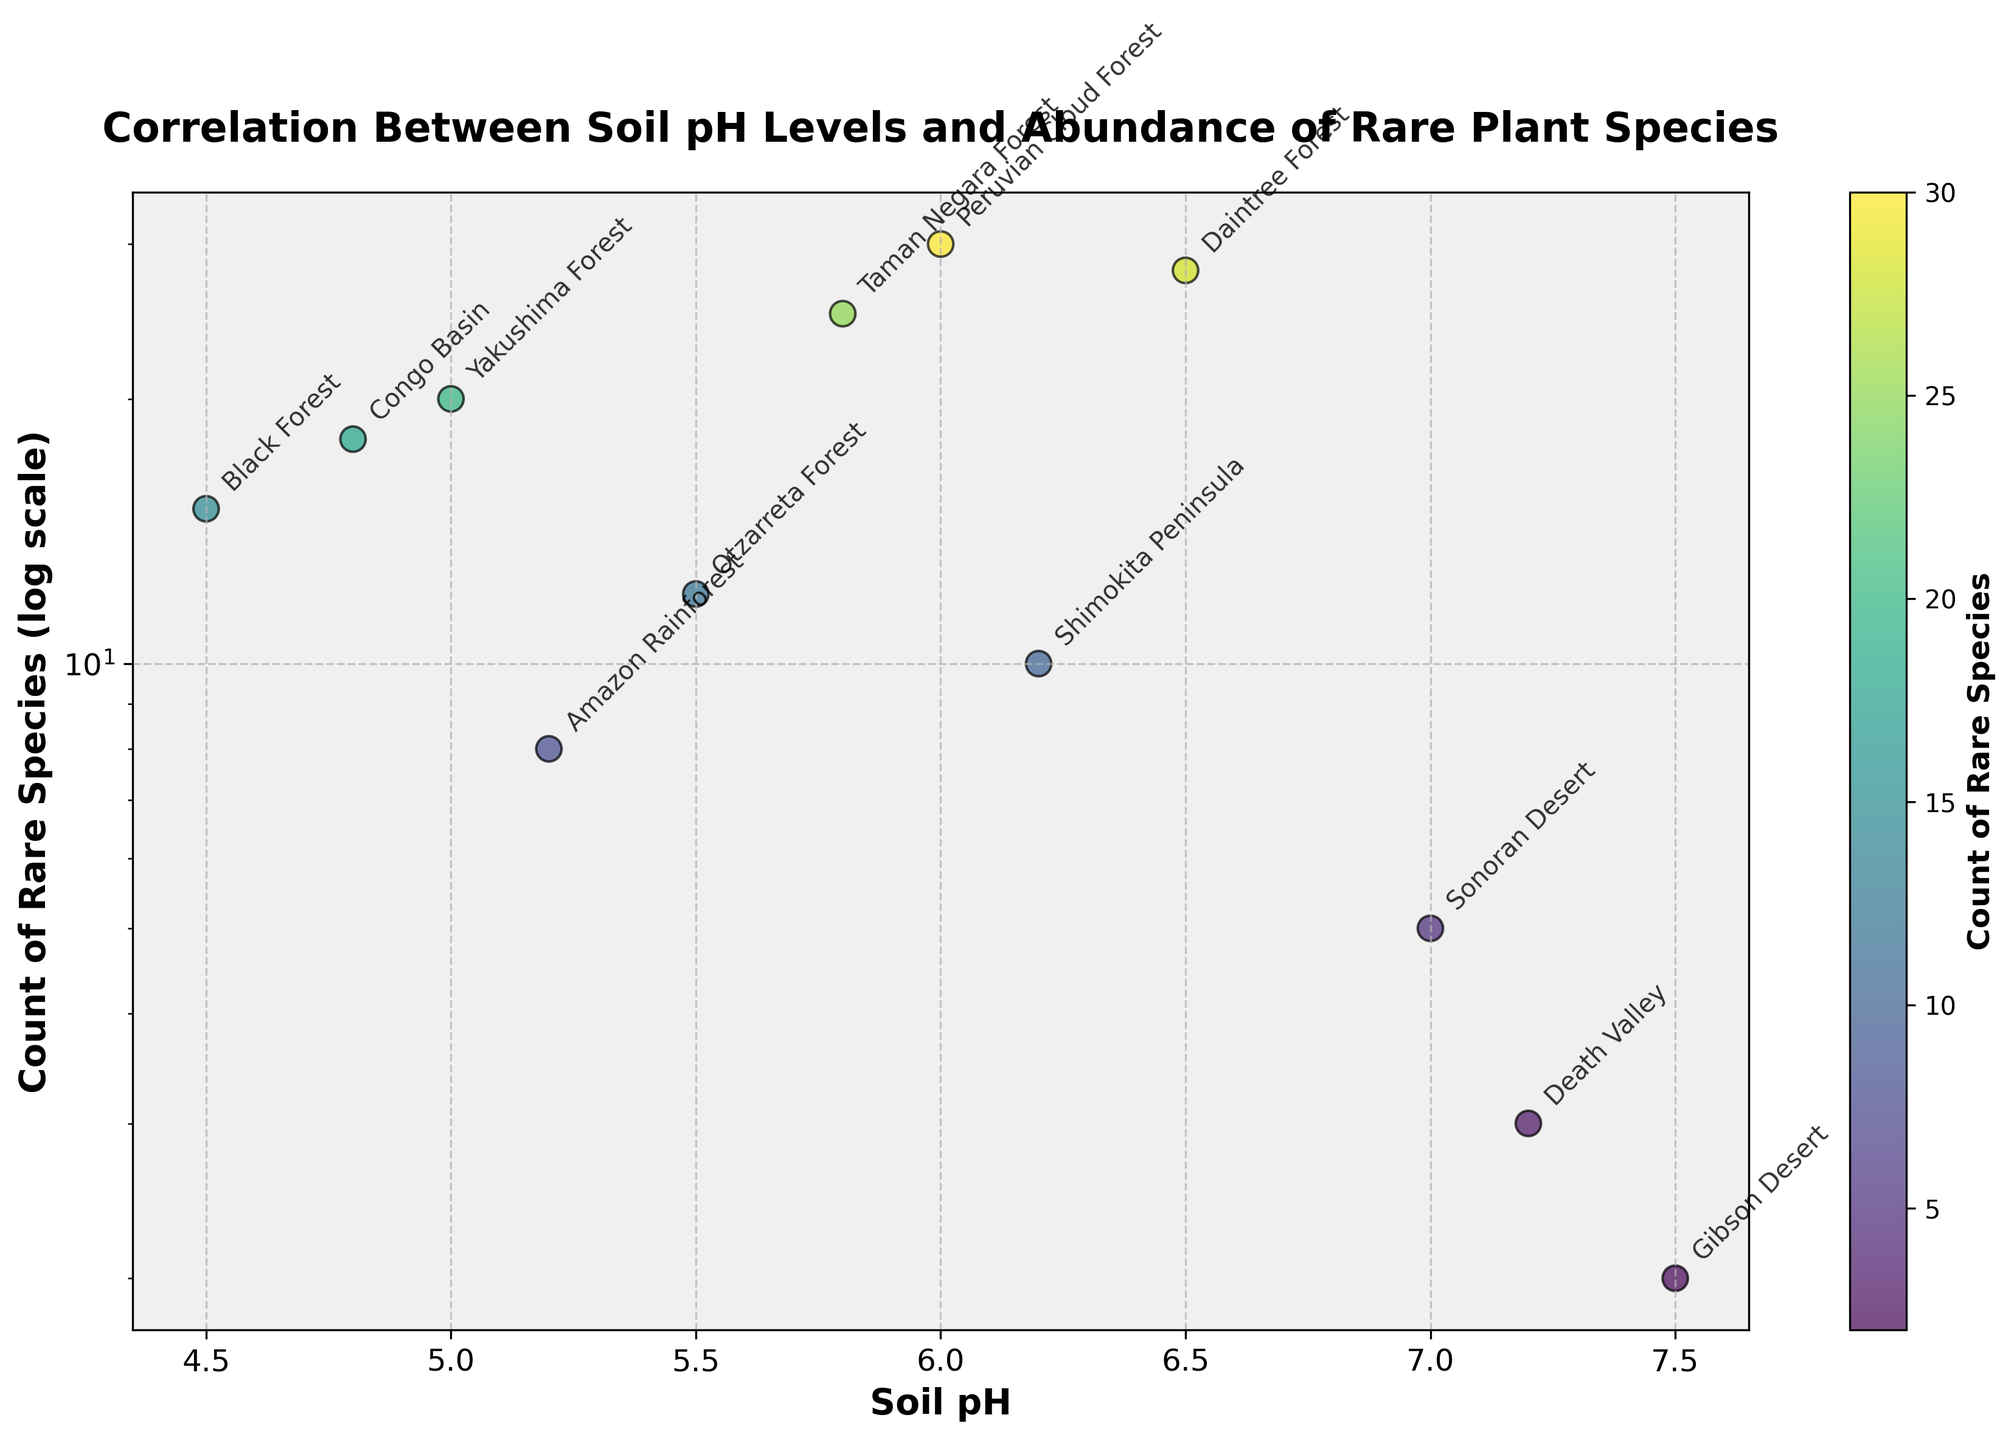What is the title of the plot? The title of the plot is typically found at the top center of the figure. Reading from the provided description, the title is "Correlation Between Soil pH Levels and Abundance of Rare Plant Species".
Answer: Correlation Between Soil pH Levels and Abundance of Rare Plant Species What are the two variables plotted on the axis? The variables are indicated by the axis labels. The x-axis shows "Soil pH" and the y-axis shows "Count of Rare Species (log scale)".
Answer: Soil pH and Count of Rare Species (log scale) How many locations have a Soil pH greater than 6.0? To answer this, look at the x-axis for values greater than 6.0 and count the number of corresponding data points. The locations are Sonoran Desert, Death Valley, and Gibson Desert. There are three points.
Answer: 3 Which location has the highest count of rare species? Look at the y-axis and identify the highest point on the scatter plot. The location with the highest count of rare species is the Peruvian Cloud Forest with a count of 30.
Answer: Peruvian Cloud Forest Which location has the lowest count of rare species? Look for the lowest point on the y-axis in the scatter plot. The location with the lowest count of rare species is the Gibson Desert with a count of 2.
Answer: Gibson Desert What is the soil pH level where the count of rare species is 18? Find the data point where the y-axis shows 18, then check the x-axis for the corresponding Soil pH level. The soil pH level is 4.8, corresponding to the Congo Basin.
Answer: 4.8 Compare the count of rare species between the Black Forest and the Sonoran Desert. Which one has more rare species? Locate the points for Black Forest and Sonoran Desert. Compare their y-axis values. Black Forest has a count of 15, while Sonoran Desert has a count of 5. Therefore, Black Forest has more rare species.
Answer: Black Forest Is there a general trend between Soil pH levels and the abundance of rare plant species? Observing the scatter plot, most points with higher counts of rare species tend to cluster around lower to mid soil pH levels, hinting at a negative correlation. As pH level increases, the count of rare species generally decreases.
Answer: Negative correlation What is the average Soil pH level for locations with more than 10 rare species? First, identify points with y-values greater than 10 (4.5, 5.0, 5.5, 6.0, 5.8, 6.5). Sum their x-values and divide by the number of points: (4.5 + 5.0 + 5.5 + 6.0 + 5.8 + 6.5)/6 = 33.3 / 6 ≈ 5.55.
Answer: 5.55 Which location has a Soil pH of exactly 5.0? Check the scatter plot for the point where the x-axis is at 5.0 and then read the corresponding location label. The location is Yakushima Forest.
Answer: Yakushima Forest 